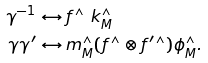Convert formula to latex. <formula><loc_0><loc_0><loc_500><loc_500>\gamma ^ { - 1 } & \leftrightarrow f ^ { \wedge } \ k ^ { \wedge } _ { M } \\ \gamma \gamma ^ { \prime } & \leftrightarrow m ^ { \wedge } _ { M } ( f ^ { \wedge } \otimes { f } ^ { \prime \wedge } ) \phi ^ { \wedge } _ { M } .</formula> 